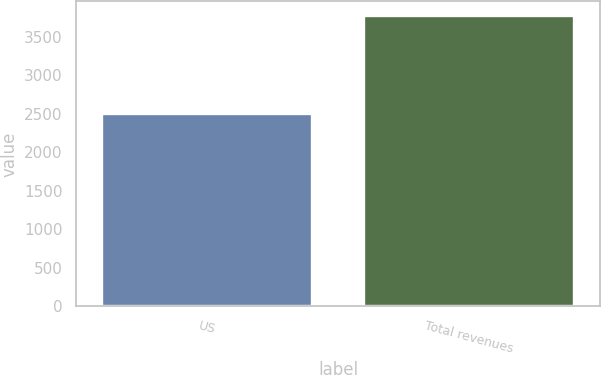<chart> <loc_0><loc_0><loc_500><loc_500><bar_chart><fcel>US<fcel>Total revenues<nl><fcel>2504<fcel>3773<nl></chart> 